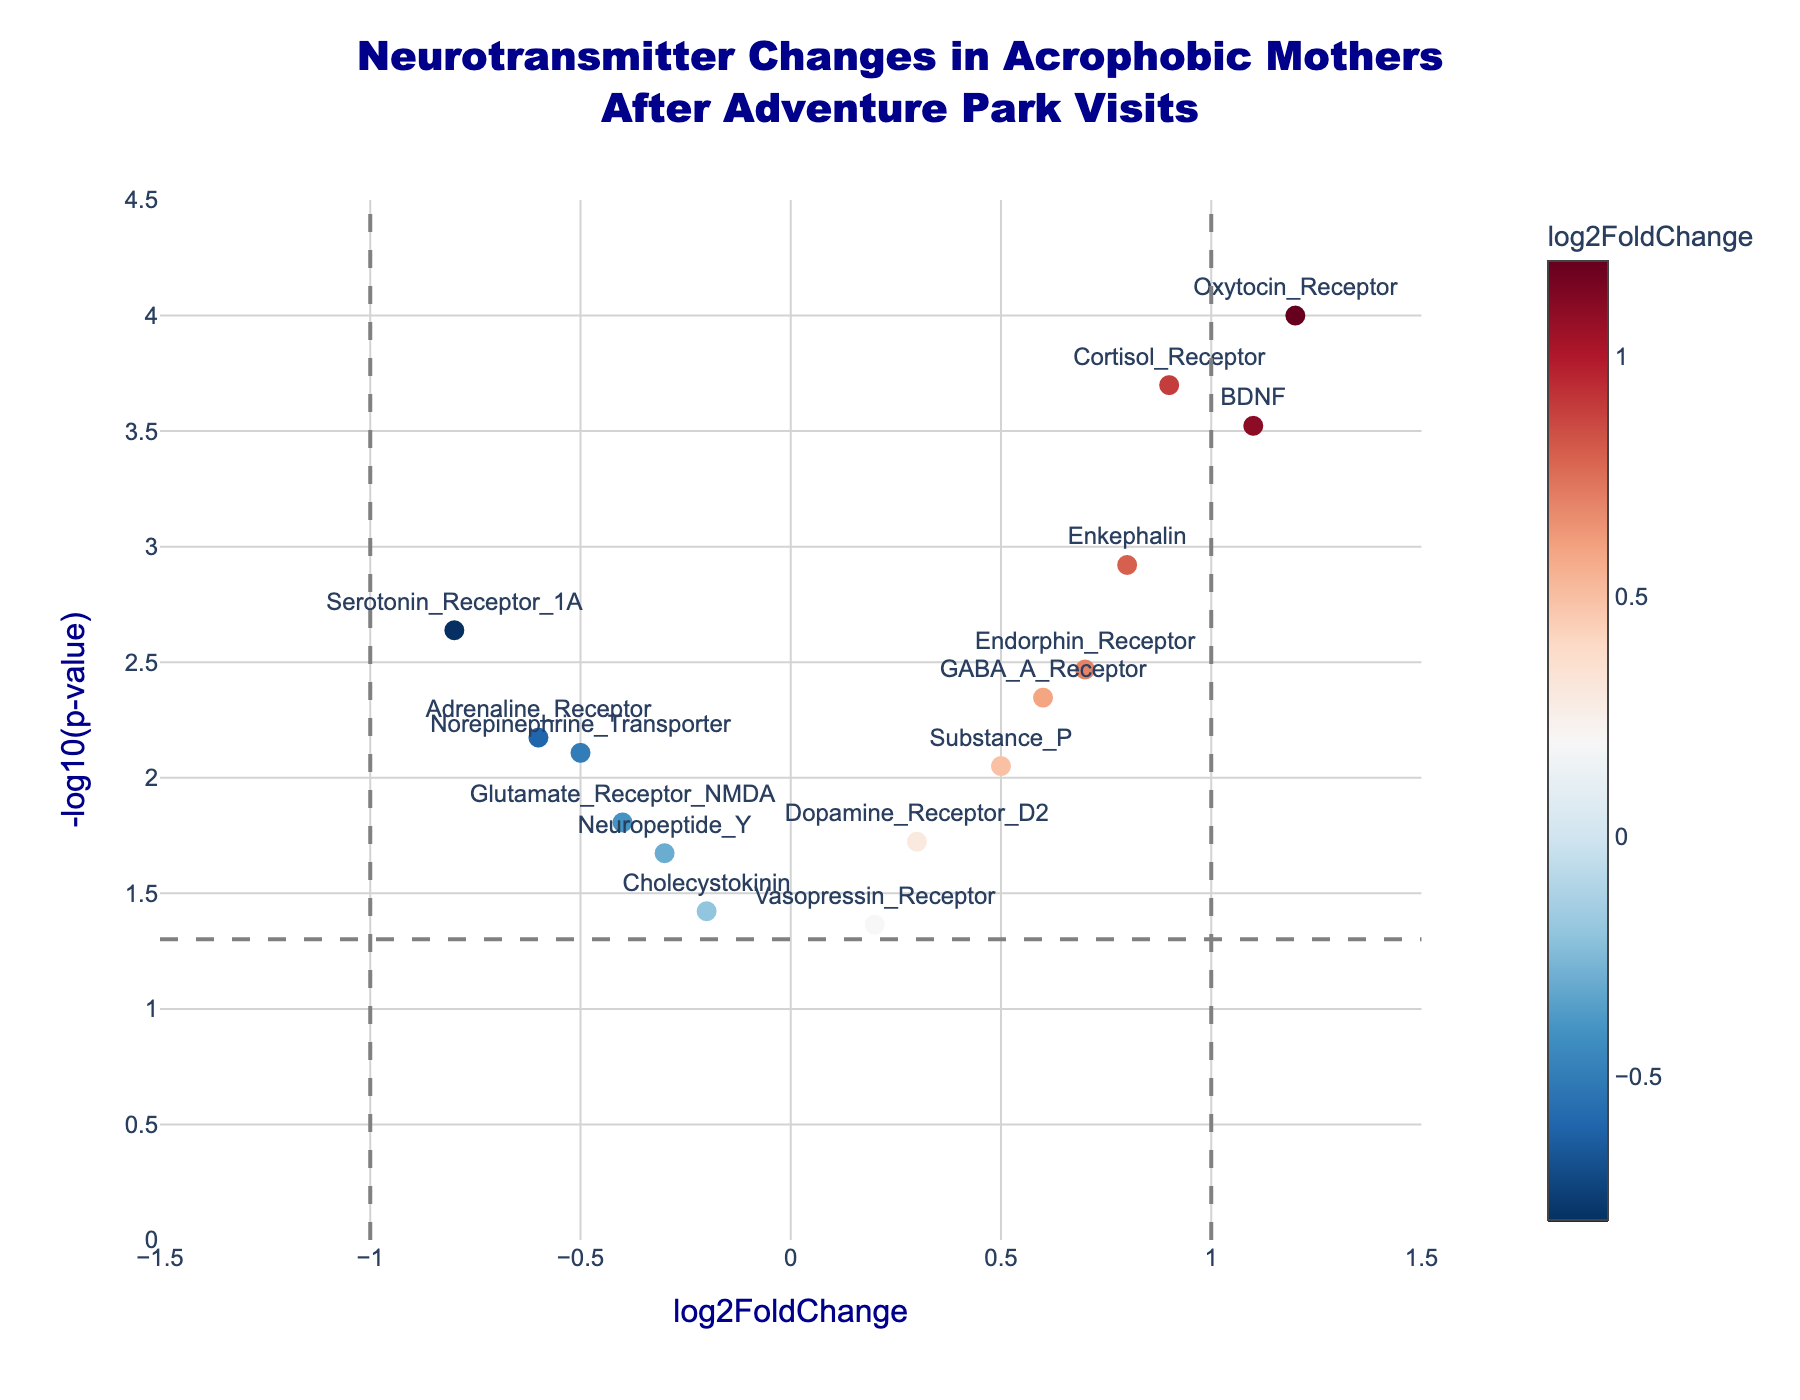Here are the question-answer pairs following the provided format:
 
What is the title of the plot? The title is typically displayed at the top center of the plot. In this case, the title reads "Neurotransmitter Changes in Acrophobic Mothers After Adventure Park Visits."
Answer: Neurotransmitter Changes in Acrophobic Mothers After Adventure Park Visits How many neurotransmitters have a log2FoldChange greater than 1? By looking at the x-axis (log2FoldChange), and noting points right of the vertical line at 1, we see two points lying in that area: Oxytocin_Receptor and BDNF.
Answer: 2 Which neurotransmitter has the most significant change indicated by the lowest p-value? The -log10(p-value) is highest for the neurotransmitter with the lowest p-value. By examining the y-axis (higher values), Oxytocin_Receptor is the highest at -log10(p-value) = 4.
Answer: Oxytocin_Receptor What are the x and y-axis labels in this plot? The x-axis label, shown at the bottom along the horizontal axis, is "log2FoldChange." The y-axis label, shown beside the vertical axis, is "-log10(p-value)."
Answer: log2FoldChange and -log10(p-value) How does the Endorphin_Receptor's log2FoldChange compare to that of the Serotonin_Receptor_1A? Endorphin_Receptor is to the right with a log2FoldChange of 0.7, while Serotonin_Receptor_1A is to the left with a log2FoldChange of -0.8. Hence Endorphin_Receptor has a higher log2FoldChange.
Answer: Endorphin_Receptor has a higher log2FoldChange Which neurotransmitter has the second-lowest p-value? By examining the -log10(p-value) and identifying the second highest point (since larger -log10(p-value) means smaller p-value), the point corresponding to Cortisol_Receptor is notably second after Oxytocin_Receptor.
Answer: Cortisol_Receptor Is the log2FoldChange of Dopamine_Receptor_D2 positive or negative? Locate the position of Dopamine_Receptor_D2 on the x-axis: it has a value of 0.3 which is on the positive side of the axis.
Answer: Positive How many neurotransmitters have a p-value less than 0.01? To find this, look for points above the horizontal line representing -log10(0.01). The neurotransmitters are Serotonin_Receptor_1A, GABA_A_Receptor, Cortisol_Receptor, Oxytocin_Receptor, Endorphin_Receptor, Adrenaline_Receptor, and Enkephalin.
Answer: 7 Which neurotransmitter shows the most significant negative log2FoldChange? By observing the most left-lying point on the x-axis (negative side), Serotonin_Receptor_1A has the lowest log2FoldChange at -0.8.
Answer: Serotonin_Receptor_1A What’s the significance level indicated by the horizontal dashed line, and is the Glutamate_Receptor_NMDA above or below this threshold? The horizontal dashed line is at -log10(0.05). Since Glutamate_Receptor_NMDA's corresponding point lies above this line, it has a p-value less than 0.05, indicating significance.
Answer: Above 